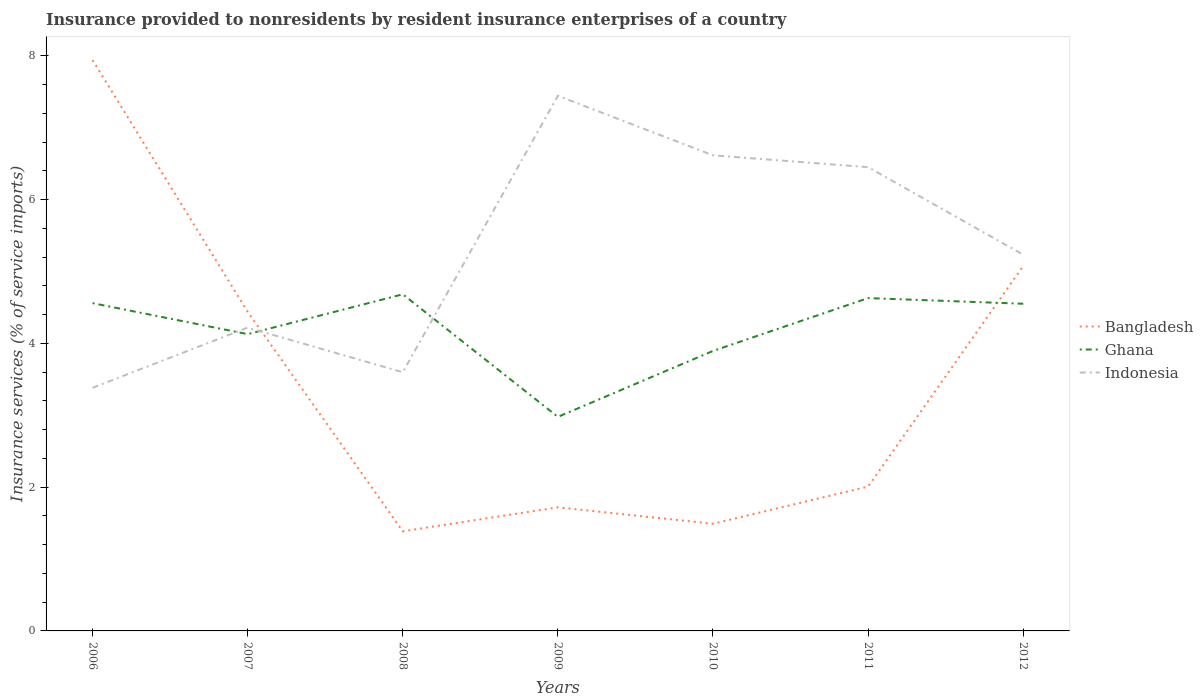How many different coloured lines are there?
Your response must be concise. 3. Does the line corresponding to Ghana intersect with the line corresponding to Indonesia?
Make the answer very short. Yes. Across all years, what is the maximum insurance provided to nonresidents in Ghana?
Offer a terse response. 2.98. What is the total insurance provided to nonresidents in Indonesia in the graph?
Your answer should be very brief. -1.64. What is the difference between the highest and the second highest insurance provided to nonresidents in Indonesia?
Your response must be concise. 4.06. What is the difference between the highest and the lowest insurance provided to nonresidents in Bangladesh?
Make the answer very short. 3. Is the insurance provided to nonresidents in Indonesia strictly greater than the insurance provided to nonresidents in Bangladesh over the years?
Offer a very short reply. No. How many lines are there?
Offer a very short reply. 3. What is the difference between two consecutive major ticks on the Y-axis?
Ensure brevity in your answer.  2. How many legend labels are there?
Provide a short and direct response. 3. What is the title of the graph?
Offer a terse response. Insurance provided to nonresidents by resident insurance enterprises of a country. What is the label or title of the X-axis?
Offer a terse response. Years. What is the label or title of the Y-axis?
Your answer should be very brief. Insurance services (% of service imports). What is the Insurance services (% of service imports) of Bangladesh in 2006?
Provide a succinct answer. 7.94. What is the Insurance services (% of service imports) in Ghana in 2006?
Provide a short and direct response. 4.56. What is the Insurance services (% of service imports) of Indonesia in 2006?
Ensure brevity in your answer.  3.38. What is the Insurance services (% of service imports) of Bangladesh in 2007?
Your answer should be very brief. 4.44. What is the Insurance services (% of service imports) of Ghana in 2007?
Give a very brief answer. 4.13. What is the Insurance services (% of service imports) in Indonesia in 2007?
Offer a terse response. 4.22. What is the Insurance services (% of service imports) in Bangladesh in 2008?
Offer a terse response. 1.39. What is the Insurance services (% of service imports) in Ghana in 2008?
Give a very brief answer. 4.68. What is the Insurance services (% of service imports) of Indonesia in 2008?
Ensure brevity in your answer.  3.6. What is the Insurance services (% of service imports) in Bangladesh in 2009?
Your response must be concise. 1.72. What is the Insurance services (% of service imports) of Ghana in 2009?
Give a very brief answer. 2.98. What is the Insurance services (% of service imports) in Indonesia in 2009?
Ensure brevity in your answer.  7.44. What is the Insurance services (% of service imports) in Bangladesh in 2010?
Make the answer very short. 1.49. What is the Insurance services (% of service imports) of Ghana in 2010?
Provide a short and direct response. 3.89. What is the Insurance services (% of service imports) of Indonesia in 2010?
Keep it short and to the point. 6.62. What is the Insurance services (% of service imports) in Bangladesh in 2011?
Offer a very short reply. 2.01. What is the Insurance services (% of service imports) of Ghana in 2011?
Ensure brevity in your answer.  4.63. What is the Insurance services (% of service imports) in Indonesia in 2011?
Your answer should be very brief. 6.45. What is the Insurance services (% of service imports) in Bangladesh in 2012?
Your response must be concise. 5.08. What is the Insurance services (% of service imports) in Ghana in 2012?
Ensure brevity in your answer.  4.55. What is the Insurance services (% of service imports) in Indonesia in 2012?
Offer a terse response. 5.23. Across all years, what is the maximum Insurance services (% of service imports) in Bangladesh?
Ensure brevity in your answer.  7.94. Across all years, what is the maximum Insurance services (% of service imports) in Ghana?
Provide a short and direct response. 4.68. Across all years, what is the maximum Insurance services (% of service imports) of Indonesia?
Your answer should be compact. 7.44. Across all years, what is the minimum Insurance services (% of service imports) of Bangladesh?
Your answer should be very brief. 1.39. Across all years, what is the minimum Insurance services (% of service imports) in Ghana?
Give a very brief answer. 2.98. Across all years, what is the minimum Insurance services (% of service imports) in Indonesia?
Ensure brevity in your answer.  3.38. What is the total Insurance services (% of service imports) of Bangladesh in the graph?
Your answer should be very brief. 24.06. What is the total Insurance services (% of service imports) in Ghana in the graph?
Make the answer very short. 29.42. What is the total Insurance services (% of service imports) of Indonesia in the graph?
Ensure brevity in your answer.  36.94. What is the difference between the Insurance services (% of service imports) in Bangladesh in 2006 and that in 2007?
Offer a terse response. 3.5. What is the difference between the Insurance services (% of service imports) in Ghana in 2006 and that in 2007?
Provide a short and direct response. 0.43. What is the difference between the Insurance services (% of service imports) in Indonesia in 2006 and that in 2007?
Offer a terse response. -0.84. What is the difference between the Insurance services (% of service imports) in Bangladesh in 2006 and that in 2008?
Keep it short and to the point. 6.55. What is the difference between the Insurance services (% of service imports) in Ghana in 2006 and that in 2008?
Provide a succinct answer. -0.12. What is the difference between the Insurance services (% of service imports) in Indonesia in 2006 and that in 2008?
Ensure brevity in your answer.  -0.22. What is the difference between the Insurance services (% of service imports) in Bangladesh in 2006 and that in 2009?
Give a very brief answer. 6.22. What is the difference between the Insurance services (% of service imports) of Ghana in 2006 and that in 2009?
Make the answer very short. 1.58. What is the difference between the Insurance services (% of service imports) in Indonesia in 2006 and that in 2009?
Provide a succinct answer. -4.06. What is the difference between the Insurance services (% of service imports) in Bangladesh in 2006 and that in 2010?
Ensure brevity in your answer.  6.45. What is the difference between the Insurance services (% of service imports) of Ghana in 2006 and that in 2010?
Make the answer very short. 0.66. What is the difference between the Insurance services (% of service imports) in Indonesia in 2006 and that in 2010?
Offer a very short reply. -3.23. What is the difference between the Insurance services (% of service imports) of Bangladesh in 2006 and that in 2011?
Your answer should be compact. 5.93. What is the difference between the Insurance services (% of service imports) in Ghana in 2006 and that in 2011?
Offer a very short reply. -0.07. What is the difference between the Insurance services (% of service imports) of Indonesia in 2006 and that in 2011?
Make the answer very short. -3.07. What is the difference between the Insurance services (% of service imports) in Bangladesh in 2006 and that in 2012?
Ensure brevity in your answer.  2.86. What is the difference between the Insurance services (% of service imports) in Ghana in 2006 and that in 2012?
Offer a terse response. 0.01. What is the difference between the Insurance services (% of service imports) of Indonesia in 2006 and that in 2012?
Offer a terse response. -1.85. What is the difference between the Insurance services (% of service imports) of Bangladesh in 2007 and that in 2008?
Your answer should be very brief. 3.05. What is the difference between the Insurance services (% of service imports) in Ghana in 2007 and that in 2008?
Offer a terse response. -0.55. What is the difference between the Insurance services (% of service imports) in Indonesia in 2007 and that in 2008?
Make the answer very short. 0.62. What is the difference between the Insurance services (% of service imports) in Bangladesh in 2007 and that in 2009?
Provide a succinct answer. 2.72. What is the difference between the Insurance services (% of service imports) in Ghana in 2007 and that in 2009?
Make the answer very short. 1.15. What is the difference between the Insurance services (% of service imports) of Indonesia in 2007 and that in 2009?
Provide a succinct answer. -3.22. What is the difference between the Insurance services (% of service imports) in Bangladesh in 2007 and that in 2010?
Your answer should be compact. 2.95. What is the difference between the Insurance services (% of service imports) of Ghana in 2007 and that in 2010?
Your answer should be very brief. 0.23. What is the difference between the Insurance services (% of service imports) of Indonesia in 2007 and that in 2010?
Provide a succinct answer. -2.4. What is the difference between the Insurance services (% of service imports) of Bangladesh in 2007 and that in 2011?
Your answer should be very brief. 2.43. What is the difference between the Insurance services (% of service imports) in Ghana in 2007 and that in 2011?
Offer a very short reply. -0.5. What is the difference between the Insurance services (% of service imports) of Indonesia in 2007 and that in 2011?
Your answer should be compact. -2.23. What is the difference between the Insurance services (% of service imports) of Bangladesh in 2007 and that in 2012?
Offer a very short reply. -0.64. What is the difference between the Insurance services (% of service imports) in Ghana in 2007 and that in 2012?
Offer a very short reply. -0.42. What is the difference between the Insurance services (% of service imports) in Indonesia in 2007 and that in 2012?
Your answer should be compact. -1.01. What is the difference between the Insurance services (% of service imports) of Bangladesh in 2008 and that in 2009?
Provide a succinct answer. -0.33. What is the difference between the Insurance services (% of service imports) of Ghana in 2008 and that in 2009?
Your answer should be very brief. 1.71. What is the difference between the Insurance services (% of service imports) in Indonesia in 2008 and that in 2009?
Your response must be concise. -3.85. What is the difference between the Insurance services (% of service imports) of Bangladesh in 2008 and that in 2010?
Keep it short and to the point. -0.1. What is the difference between the Insurance services (% of service imports) in Ghana in 2008 and that in 2010?
Ensure brevity in your answer.  0.79. What is the difference between the Insurance services (% of service imports) of Indonesia in 2008 and that in 2010?
Your response must be concise. -3.02. What is the difference between the Insurance services (% of service imports) of Bangladesh in 2008 and that in 2011?
Provide a succinct answer. -0.62. What is the difference between the Insurance services (% of service imports) in Ghana in 2008 and that in 2011?
Ensure brevity in your answer.  0.05. What is the difference between the Insurance services (% of service imports) of Indonesia in 2008 and that in 2011?
Offer a terse response. -2.85. What is the difference between the Insurance services (% of service imports) in Bangladesh in 2008 and that in 2012?
Provide a succinct answer. -3.69. What is the difference between the Insurance services (% of service imports) of Ghana in 2008 and that in 2012?
Provide a succinct answer. 0.13. What is the difference between the Insurance services (% of service imports) of Indonesia in 2008 and that in 2012?
Ensure brevity in your answer.  -1.64. What is the difference between the Insurance services (% of service imports) in Bangladesh in 2009 and that in 2010?
Provide a succinct answer. 0.23. What is the difference between the Insurance services (% of service imports) of Ghana in 2009 and that in 2010?
Provide a short and direct response. -0.92. What is the difference between the Insurance services (% of service imports) in Indonesia in 2009 and that in 2010?
Make the answer very short. 0.83. What is the difference between the Insurance services (% of service imports) in Bangladesh in 2009 and that in 2011?
Offer a very short reply. -0.29. What is the difference between the Insurance services (% of service imports) of Ghana in 2009 and that in 2011?
Give a very brief answer. -1.65. What is the difference between the Insurance services (% of service imports) of Indonesia in 2009 and that in 2011?
Your response must be concise. 0.99. What is the difference between the Insurance services (% of service imports) of Bangladesh in 2009 and that in 2012?
Provide a succinct answer. -3.36. What is the difference between the Insurance services (% of service imports) of Ghana in 2009 and that in 2012?
Offer a very short reply. -1.57. What is the difference between the Insurance services (% of service imports) of Indonesia in 2009 and that in 2012?
Offer a terse response. 2.21. What is the difference between the Insurance services (% of service imports) in Bangladesh in 2010 and that in 2011?
Your answer should be very brief. -0.52. What is the difference between the Insurance services (% of service imports) in Ghana in 2010 and that in 2011?
Your response must be concise. -0.74. What is the difference between the Insurance services (% of service imports) in Indonesia in 2010 and that in 2011?
Provide a succinct answer. 0.16. What is the difference between the Insurance services (% of service imports) in Bangladesh in 2010 and that in 2012?
Provide a succinct answer. -3.59. What is the difference between the Insurance services (% of service imports) in Ghana in 2010 and that in 2012?
Keep it short and to the point. -0.66. What is the difference between the Insurance services (% of service imports) in Indonesia in 2010 and that in 2012?
Offer a very short reply. 1.38. What is the difference between the Insurance services (% of service imports) in Bangladesh in 2011 and that in 2012?
Provide a succinct answer. -3.07. What is the difference between the Insurance services (% of service imports) in Ghana in 2011 and that in 2012?
Your answer should be compact. 0.08. What is the difference between the Insurance services (% of service imports) of Indonesia in 2011 and that in 2012?
Offer a very short reply. 1.22. What is the difference between the Insurance services (% of service imports) of Bangladesh in 2006 and the Insurance services (% of service imports) of Ghana in 2007?
Ensure brevity in your answer.  3.81. What is the difference between the Insurance services (% of service imports) of Bangladesh in 2006 and the Insurance services (% of service imports) of Indonesia in 2007?
Keep it short and to the point. 3.72. What is the difference between the Insurance services (% of service imports) in Ghana in 2006 and the Insurance services (% of service imports) in Indonesia in 2007?
Your answer should be compact. 0.34. What is the difference between the Insurance services (% of service imports) of Bangladesh in 2006 and the Insurance services (% of service imports) of Ghana in 2008?
Your response must be concise. 3.26. What is the difference between the Insurance services (% of service imports) of Bangladesh in 2006 and the Insurance services (% of service imports) of Indonesia in 2008?
Give a very brief answer. 4.34. What is the difference between the Insurance services (% of service imports) of Ghana in 2006 and the Insurance services (% of service imports) of Indonesia in 2008?
Your answer should be compact. 0.96. What is the difference between the Insurance services (% of service imports) in Bangladesh in 2006 and the Insurance services (% of service imports) in Ghana in 2009?
Your answer should be compact. 4.96. What is the difference between the Insurance services (% of service imports) in Bangladesh in 2006 and the Insurance services (% of service imports) in Indonesia in 2009?
Your response must be concise. 0.5. What is the difference between the Insurance services (% of service imports) in Ghana in 2006 and the Insurance services (% of service imports) in Indonesia in 2009?
Provide a succinct answer. -2.88. What is the difference between the Insurance services (% of service imports) in Bangladesh in 2006 and the Insurance services (% of service imports) in Ghana in 2010?
Make the answer very short. 4.05. What is the difference between the Insurance services (% of service imports) in Bangladesh in 2006 and the Insurance services (% of service imports) in Indonesia in 2010?
Your response must be concise. 1.32. What is the difference between the Insurance services (% of service imports) of Ghana in 2006 and the Insurance services (% of service imports) of Indonesia in 2010?
Your answer should be very brief. -2.06. What is the difference between the Insurance services (% of service imports) in Bangladesh in 2006 and the Insurance services (% of service imports) in Ghana in 2011?
Your response must be concise. 3.31. What is the difference between the Insurance services (% of service imports) in Bangladesh in 2006 and the Insurance services (% of service imports) in Indonesia in 2011?
Make the answer very short. 1.49. What is the difference between the Insurance services (% of service imports) of Ghana in 2006 and the Insurance services (% of service imports) of Indonesia in 2011?
Make the answer very short. -1.89. What is the difference between the Insurance services (% of service imports) of Bangladesh in 2006 and the Insurance services (% of service imports) of Ghana in 2012?
Offer a terse response. 3.39. What is the difference between the Insurance services (% of service imports) in Bangladesh in 2006 and the Insurance services (% of service imports) in Indonesia in 2012?
Give a very brief answer. 2.71. What is the difference between the Insurance services (% of service imports) in Ghana in 2006 and the Insurance services (% of service imports) in Indonesia in 2012?
Provide a short and direct response. -0.67. What is the difference between the Insurance services (% of service imports) of Bangladesh in 2007 and the Insurance services (% of service imports) of Ghana in 2008?
Give a very brief answer. -0.24. What is the difference between the Insurance services (% of service imports) in Bangladesh in 2007 and the Insurance services (% of service imports) in Indonesia in 2008?
Your answer should be very brief. 0.84. What is the difference between the Insurance services (% of service imports) in Ghana in 2007 and the Insurance services (% of service imports) in Indonesia in 2008?
Your response must be concise. 0.53. What is the difference between the Insurance services (% of service imports) in Bangladesh in 2007 and the Insurance services (% of service imports) in Ghana in 2009?
Make the answer very short. 1.46. What is the difference between the Insurance services (% of service imports) in Bangladesh in 2007 and the Insurance services (% of service imports) in Indonesia in 2009?
Provide a short and direct response. -3. What is the difference between the Insurance services (% of service imports) of Ghana in 2007 and the Insurance services (% of service imports) of Indonesia in 2009?
Your answer should be compact. -3.32. What is the difference between the Insurance services (% of service imports) in Bangladesh in 2007 and the Insurance services (% of service imports) in Ghana in 2010?
Your response must be concise. 0.54. What is the difference between the Insurance services (% of service imports) of Bangladesh in 2007 and the Insurance services (% of service imports) of Indonesia in 2010?
Make the answer very short. -2.18. What is the difference between the Insurance services (% of service imports) of Ghana in 2007 and the Insurance services (% of service imports) of Indonesia in 2010?
Your answer should be compact. -2.49. What is the difference between the Insurance services (% of service imports) of Bangladesh in 2007 and the Insurance services (% of service imports) of Ghana in 2011?
Provide a short and direct response. -0.19. What is the difference between the Insurance services (% of service imports) in Bangladesh in 2007 and the Insurance services (% of service imports) in Indonesia in 2011?
Provide a succinct answer. -2.01. What is the difference between the Insurance services (% of service imports) in Ghana in 2007 and the Insurance services (% of service imports) in Indonesia in 2011?
Ensure brevity in your answer.  -2.32. What is the difference between the Insurance services (% of service imports) of Bangladesh in 2007 and the Insurance services (% of service imports) of Ghana in 2012?
Your response must be concise. -0.11. What is the difference between the Insurance services (% of service imports) of Bangladesh in 2007 and the Insurance services (% of service imports) of Indonesia in 2012?
Give a very brief answer. -0.79. What is the difference between the Insurance services (% of service imports) of Ghana in 2007 and the Insurance services (% of service imports) of Indonesia in 2012?
Make the answer very short. -1.11. What is the difference between the Insurance services (% of service imports) in Bangladesh in 2008 and the Insurance services (% of service imports) in Ghana in 2009?
Offer a terse response. -1.59. What is the difference between the Insurance services (% of service imports) of Bangladesh in 2008 and the Insurance services (% of service imports) of Indonesia in 2009?
Ensure brevity in your answer.  -6.06. What is the difference between the Insurance services (% of service imports) in Ghana in 2008 and the Insurance services (% of service imports) in Indonesia in 2009?
Make the answer very short. -2.76. What is the difference between the Insurance services (% of service imports) in Bangladesh in 2008 and the Insurance services (% of service imports) in Ghana in 2010?
Give a very brief answer. -2.51. What is the difference between the Insurance services (% of service imports) of Bangladesh in 2008 and the Insurance services (% of service imports) of Indonesia in 2010?
Offer a terse response. -5.23. What is the difference between the Insurance services (% of service imports) of Ghana in 2008 and the Insurance services (% of service imports) of Indonesia in 2010?
Make the answer very short. -1.93. What is the difference between the Insurance services (% of service imports) in Bangladesh in 2008 and the Insurance services (% of service imports) in Ghana in 2011?
Ensure brevity in your answer.  -3.24. What is the difference between the Insurance services (% of service imports) of Bangladesh in 2008 and the Insurance services (% of service imports) of Indonesia in 2011?
Your answer should be compact. -5.07. What is the difference between the Insurance services (% of service imports) of Ghana in 2008 and the Insurance services (% of service imports) of Indonesia in 2011?
Provide a short and direct response. -1.77. What is the difference between the Insurance services (% of service imports) in Bangladesh in 2008 and the Insurance services (% of service imports) in Ghana in 2012?
Offer a terse response. -3.17. What is the difference between the Insurance services (% of service imports) in Bangladesh in 2008 and the Insurance services (% of service imports) in Indonesia in 2012?
Offer a terse response. -3.85. What is the difference between the Insurance services (% of service imports) in Ghana in 2008 and the Insurance services (% of service imports) in Indonesia in 2012?
Provide a succinct answer. -0.55. What is the difference between the Insurance services (% of service imports) in Bangladesh in 2009 and the Insurance services (% of service imports) in Ghana in 2010?
Keep it short and to the point. -2.18. What is the difference between the Insurance services (% of service imports) of Bangladesh in 2009 and the Insurance services (% of service imports) of Indonesia in 2010?
Your answer should be compact. -4.9. What is the difference between the Insurance services (% of service imports) of Ghana in 2009 and the Insurance services (% of service imports) of Indonesia in 2010?
Your response must be concise. -3.64. What is the difference between the Insurance services (% of service imports) in Bangladesh in 2009 and the Insurance services (% of service imports) in Ghana in 2011?
Provide a short and direct response. -2.91. What is the difference between the Insurance services (% of service imports) of Bangladesh in 2009 and the Insurance services (% of service imports) of Indonesia in 2011?
Ensure brevity in your answer.  -4.73. What is the difference between the Insurance services (% of service imports) of Ghana in 2009 and the Insurance services (% of service imports) of Indonesia in 2011?
Your answer should be very brief. -3.47. What is the difference between the Insurance services (% of service imports) in Bangladesh in 2009 and the Insurance services (% of service imports) in Ghana in 2012?
Your response must be concise. -2.83. What is the difference between the Insurance services (% of service imports) of Bangladesh in 2009 and the Insurance services (% of service imports) of Indonesia in 2012?
Provide a short and direct response. -3.51. What is the difference between the Insurance services (% of service imports) of Ghana in 2009 and the Insurance services (% of service imports) of Indonesia in 2012?
Your response must be concise. -2.26. What is the difference between the Insurance services (% of service imports) of Bangladesh in 2010 and the Insurance services (% of service imports) of Ghana in 2011?
Offer a very short reply. -3.14. What is the difference between the Insurance services (% of service imports) in Bangladesh in 2010 and the Insurance services (% of service imports) in Indonesia in 2011?
Your response must be concise. -4.96. What is the difference between the Insurance services (% of service imports) of Ghana in 2010 and the Insurance services (% of service imports) of Indonesia in 2011?
Provide a short and direct response. -2.56. What is the difference between the Insurance services (% of service imports) of Bangladesh in 2010 and the Insurance services (% of service imports) of Ghana in 2012?
Your response must be concise. -3.06. What is the difference between the Insurance services (% of service imports) in Bangladesh in 2010 and the Insurance services (% of service imports) in Indonesia in 2012?
Provide a short and direct response. -3.74. What is the difference between the Insurance services (% of service imports) of Ghana in 2010 and the Insurance services (% of service imports) of Indonesia in 2012?
Offer a terse response. -1.34. What is the difference between the Insurance services (% of service imports) in Bangladesh in 2011 and the Insurance services (% of service imports) in Ghana in 2012?
Offer a terse response. -2.54. What is the difference between the Insurance services (% of service imports) of Bangladesh in 2011 and the Insurance services (% of service imports) of Indonesia in 2012?
Your response must be concise. -3.23. What is the difference between the Insurance services (% of service imports) in Ghana in 2011 and the Insurance services (% of service imports) in Indonesia in 2012?
Give a very brief answer. -0.6. What is the average Insurance services (% of service imports) of Bangladesh per year?
Make the answer very short. 3.44. What is the average Insurance services (% of service imports) in Ghana per year?
Provide a succinct answer. 4.2. What is the average Insurance services (% of service imports) in Indonesia per year?
Offer a terse response. 5.28. In the year 2006, what is the difference between the Insurance services (% of service imports) of Bangladesh and Insurance services (% of service imports) of Ghana?
Your answer should be very brief. 3.38. In the year 2006, what is the difference between the Insurance services (% of service imports) in Bangladesh and Insurance services (% of service imports) in Indonesia?
Your answer should be very brief. 4.56. In the year 2006, what is the difference between the Insurance services (% of service imports) of Ghana and Insurance services (% of service imports) of Indonesia?
Offer a terse response. 1.18. In the year 2007, what is the difference between the Insurance services (% of service imports) of Bangladesh and Insurance services (% of service imports) of Ghana?
Give a very brief answer. 0.31. In the year 2007, what is the difference between the Insurance services (% of service imports) in Bangladesh and Insurance services (% of service imports) in Indonesia?
Your response must be concise. 0.22. In the year 2007, what is the difference between the Insurance services (% of service imports) in Ghana and Insurance services (% of service imports) in Indonesia?
Provide a succinct answer. -0.09. In the year 2008, what is the difference between the Insurance services (% of service imports) of Bangladesh and Insurance services (% of service imports) of Ghana?
Keep it short and to the point. -3.3. In the year 2008, what is the difference between the Insurance services (% of service imports) in Bangladesh and Insurance services (% of service imports) in Indonesia?
Give a very brief answer. -2.21. In the year 2008, what is the difference between the Insurance services (% of service imports) in Ghana and Insurance services (% of service imports) in Indonesia?
Your answer should be compact. 1.08. In the year 2009, what is the difference between the Insurance services (% of service imports) in Bangladesh and Insurance services (% of service imports) in Ghana?
Offer a terse response. -1.26. In the year 2009, what is the difference between the Insurance services (% of service imports) in Bangladesh and Insurance services (% of service imports) in Indonesia?
Make the answer very short. -5.72. In the year 2009, what is the difference between the Insurance services (% of service imports) of Ghana and Insurance services (% of service imports) of Indonesia?
Provide a succinct answer. -4.47. In the year 2010, what is the difference between the Insurance services (% of service imports) of Bangladesh and Insurance services (% of service imports) of Ghana?
Your answer should be very brief. -2.4. In the year 2010, what is the difference between the Insurance services (% of service imports) of Bangladesh and Insurance services (% of service imports) of Indonesia?
Provide a short and direct response. -5.12. In the year 2010, what is the difference between the Insurance services (% of service imports) of Ghana and Insurance services (% of service imports) of Indonesia?
Your answer should be very brief. -2.72. In the year 2011, what is the difference between the Insurance services (% of service imports) in Bangladesh and Insurance services (% of service imports) in Ghana?
Ensure brevity in your answer.  -2.62. In the year 2011, what is the difference between the Insurance services (% of service imports) of Bangladesh and Insurance services (% of service imports) of Indonesia?
Give a very brief answer. -4.44. In the year 2011, what is the difference between the Insurance services (% of service imports) in Ghana and Insurance services (% of service imports) in Indonesia?
Keep it short and to the point. -1.82. In the year 2012, what is the difference between the Insurance services (% of service imports) in Bangladesh and Insurance services (% of service imports) in Ghana?
Your response must be concise. 0.52. In the year 2012, what is the difference between the Insurance services (% of service imports) of Bangladesh and Insurance services (% of service imports) of Indonesia?
Provide a succinct answer. -0.16. In the year 2012, what is the difference between the Insurance services (% of service imports) in Ghana and Insurance services (% of service imports) in Indonesia?
Provide a succinct answer. -0.68. What is the ratio of the Insurance services (% of service imports) of Bangladesh in 2006 to that in 2007?
Provide a short and direct response. 1.79. What is the ratio of the Insurance services (% of service imports) of Ghana in 2006 to that in 2007?
Ensure brevity in your answer.  1.1. What is the ratio of the Insurance services (% of service imports) in Indonesia in 2006 to that in 2007?
Provide a short and direct response. 0.8. What is the ratio of the Insurance services (% of service imports) in Bangladesh in 2006 to that in 2008?
Your answer should be very brief. 5.73. What is the ratio of the Insurance services (% of service imports) in Ghana in 2006 to that in 2008?
Offer a terse response. 0.97. What is the ratio of the Insurance services (% of service imports) in Bangladesh in 2006 to that in 2009?
Offer a very short reply. 4.62. What is the ratio of the Insurance services (% of service imports) in Ghana in 2006 to that in 2009?
Provide a succinct answer. 1.53. What is the ratio of the Insurance services (% of service imports) in Indonesia in 2006 to that in 2009?
Keep it short and to the point. 0.45. What is the ratio of the Insurance services (% of service imports) of Bangladesh in 2006 to that in 2010?
Offer a very short reply. 5.33. What is the ratio of the Insurance services (% of service imports) in Ghana in 2006 to that in 2010?
Your answer should be compact. 1.17. What is the ratio of the Insurance services (% of service imports) of Indonesia in 2006 to that in 2010?
Your answer should be very brief. 0.51. What is the ratio of the Insurance services (% of service imports) of Bangladesh in 2006 to that in 2011?
Offer a terse response. 3.95. What is the ratio of the Insurance services (% of service imports) of Indonesia in 2006 to that in 2011?
Offer a terse response. 0.52. What is the ratio of the Insurance services (% of service imports) in Bangladesh in 2006 to that in 2012?
Your answer should be very brief. 1.56. What is the ratio of the Insurance services (% of service imports) in Ghana in 2006 to that in 2012?
Give a very brief answer. 1. What is the ratio of the Insurance services (% of service imports) in Indonesia in 2006 to that in 2012?
Give a very brief answer. 0.65. What is the ratio of the Insurance services (% of service imports) of Bangladesh in 2007 to that in 2008?
Make the answer very short. 3.2. What is the ratio of the Insurance services (% of service imports) in Ghana in 2007 to that in 2008?
Offer a terse response. 0.88. What is the ratio of the Insurance services (% of service imports) in Indonesia in 2007 to that in 2008?
Provide a succinct answer. 1.17. What is the ratio of the Insurance services (% of service imports) in Bangladesh in 2007 to that in 2009?
Make the answer very short. 2.58. What is the ratio of the Insurance services (% of service imports) in Ghana in 2007 to that in 2009?
Give a very brief answer. 1.39. What is the ratio of the Insurance services (% of service imports) in Indonesia in 2007 to that in 2009?
Your answer should be compact. 0.57. What is the ratio of the Insurance services (% of service imports) of Bangladesh in 2007 to that in 2010?
Ensure brevity in your answer.  2.98. What is the ratio of the Insurance services (% of service imports) in Ghana in 2007 to that in 2010?
Make the answer very short. 1.06. What is the ratio of the Insurance services (% of service imports) of Indonesia in 2007 to that in 2010?
Ensure brevity in your answer.  0.64. What is the ratio of the Insurance services (% of service imports) of Bangladesh in 2007 to that in 2011?
Give a very brief answer. 2.21. What is the ratio of the Insurance services (% of service imports) of Ghana in 2007 to that in 2011?
Your answer should be very brief. 0.89. What is the ratio of the Insurance services (% of service imports) of Indonesia in 2007 to that in 2011?
Give a very brief answer. 0.65. What is the ratio of the Insurance services (% of service imports) in Bangladesh in 2007 to that in 2012?
Ensure brevity in your answer.  0.87. What is the ratio of the Insurance services (% of service imports) of Ghana in 2007 to that in 2012?
Offer a very short reply. 0.91. What is the ratio of the Insurance services (% of service imports) of Indonesia in 2007 to that in 2012?
Provide a short and direct response. 0.81. What is the ratio of the Insurance services (% of service imports) of Bangladesh in 2008 to that in 2009?
Your answer should be compact. 0.81. What is the ratio of the Insurance services (% of service imports) in Ghana in 2008 to that in 2009?
Provide a succinct answer. 1.57. What is the ratio of the Insurance services (% of service imports) of Indonesia in 2008 to that in 2009?
Your answer should be very brief. 0.48. What is the ratio of the Insurance services (% of service imports) of Bangladesh in 2008 to that in 2010?
Offer a terse response. 0.93. What is the ratio of the Insurance services (% of service imports) of Ghana in 2008 to that in 2010?
Offer a very short reply. 1.2. What is the ratio of the Insurance services (% of service imports) of Indonesia in 2008 to that in 2010?
Keep it short and to the point. 0.54. What is the ratio of the Insurance services (% of service imports) in Bangladesh in 2008 to that in 2011?
Your answer should be very brief. 0.69. What is the ratio of the Insurance services (% of service imports) of Ghana in 2008 to that in 2011?
Give a very brief answer. 1.01. What is the ratio of the Insurance services (% of service imports) in Indonesia in 2008 to that in 2011?
Ensure brevity in your answer.  0.56. What is the ratio of the Insurance services (% of service imports) of Bangladesh in 2008 to that in 2012?
Make the answer very short. 0.27. What is the ratio of the Insurance services (% of service imports) in Ghana in 2008 to that in 2012?
Your answer should be very brief. 1.03. What is the ratio of the Insurance services (% of service imports) in Indonesia in 2008 to that in 2012?
Offer a terse response. 0.69. What is the ratio of the Insurance services (% of service imports) in Bangladesh in 2009 to that in 2010?
Your answer should be very brief. 1.15. What is the ratio of the Insurance services (% of service imports) of Ghana in 2009 to that in 2010?
Provide a succinct answer. 0.76. What is the ratio of the Insurance services (% of service imports) in Indonesia in 2009 to that in 2010?
Your response must be concise. 1.13. What is the ratio of the Insurance services (% of service imports) of Bangladesh in 2009 to that in 2011?
Ensure brevity in your answer.  0.86. What is the ratio of the Insurance services (% of service imports) in Ghana in 2009 to that in 2011?
Offer a very short reply. 0.64. What is the ratio of the Insurance services (% of service imports) in Indonesia in 2009 to that in 2011?
Your answer should be compact. 1.15. What is the ratio of the Insurance services (% of service imports) of Bangladesh in 2009 to that in 2012?
Your answer should be compact. 0.34. What is the ratio of the Insurance services (% of service imports) in Ghana in 2009 to that in 2012?
Your answer should be very brief. 0.65. What is the ratio of the Insurance services (% of service imports) of Indonesia in 2009 to that in 2012?
Provide a succinct answer. 1.42. What is the ratio of the Insurance services (% of service imports) of Bangladesh in 2010 to that in 2011?
Keep it short and to the point. 0.74. What is the ratio of the Insurance services (% of service imports) of Ghana in 2010 to that in 2011?
Ensure brevity in your answer.  0.84. What is the ratio of the Insurance services (% of service imports) in Indonesia in 2010 to that in 2011?
Offer a very short reply. 1.03. What is the ratio of the Insurance services (% of service imports) of Bangladesh in 2010 to that in 2012?
Give a very brief answer. 0.29. What is the ratio of the Insurance services (% of service imports) in Ghana in 2010 to that in 2012?
Keep it short and to the point. 0.86. What is the ratio of the Insurance services (% of service imports) of Indonesia in 2010 to that in 2012?
Your answer should be very brief. 1.26. What is the ratio of the Insurance services (% of service imports) in Bangladesh in 2011 to that in 2012?
Offer a very short reply. 0.4. What is the ratio of the Insurance services (% of service imports) in Ghana in 2011 to that in 2012?
Offer a very short reply. 1.02. What is the ratio of the Insurance services (% of service imports) in Indonesia in 2011 to that in 2012?
Your response must be concise. 1.23. What is the difference between the highest and the second highest Insurance services (% of service imports) in Bangladesh?
Provide a short and direct response. 2.86. What is the difference between the highest and the second highest Insurance services (% of service imports) in Ghana?
Offer a terse response. 0.05. What is the difference between the highest and the second highest Insurance services (% of service imports) in Indonesia?
Make the answer very short. 0.83. What is the difference between the highest and the lowest Insurance services (% of service imports) in Bangladesh?
Offer a terse response. 6.55. What is the difference between the highest and the lowest Insurance services (% of service imports) in Ghana?
Keep it short and to the point. 1.71. What is the difference between the highest and the lowest Insurance services (% of service imports) in Indonesia?
Keep it short and to the point. 4.06. 